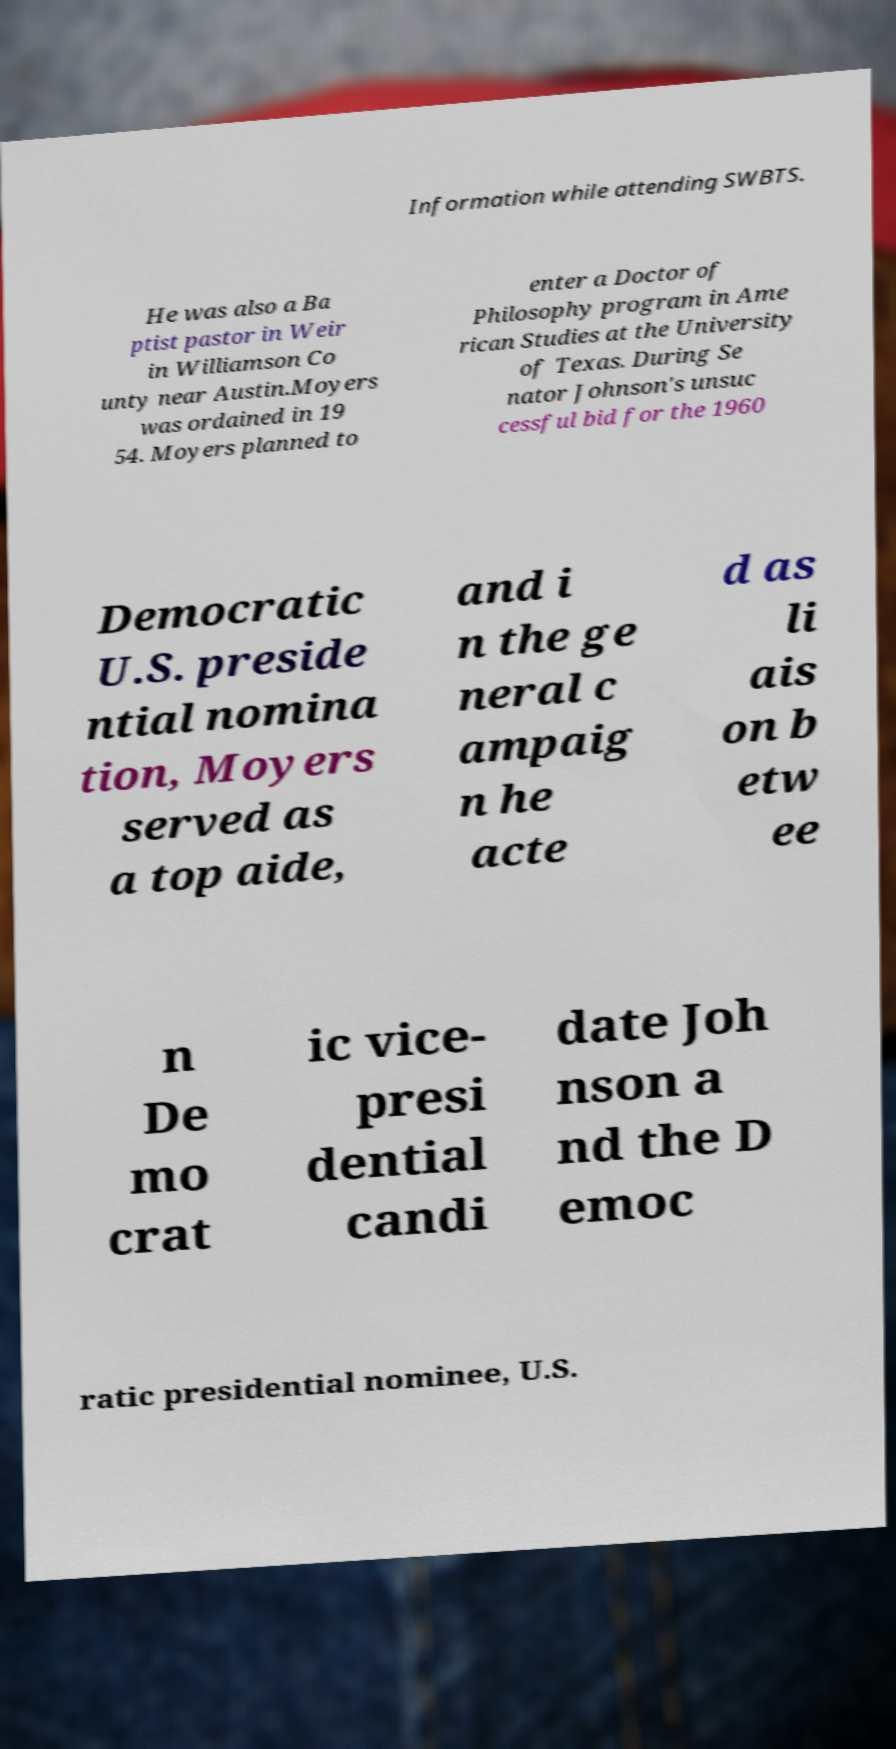There's text embedded in this image that I need extracted. Can you transcribe it verbatim? Information while attending SWBTS. He was also a Ba ptist pastor in Weir in Williamson Co unty near Austin.Moyers was ordained in 19 54. Moyers planned to enter a Doctor of Philosophy program in Ame rican Studies at the University of Texas. During Se nator Johnson's unsuc cessful bid for the 1960 Democratic U.S. preside ntial nomina tion, Moyers served as a top aide, and i n the ge neral c ampaig n he acte d as li ais on b etw ee n De mo crat ic vice- presi dential candi date Joh nson a nd the D emoc ratic presidential nominee, U.S. 